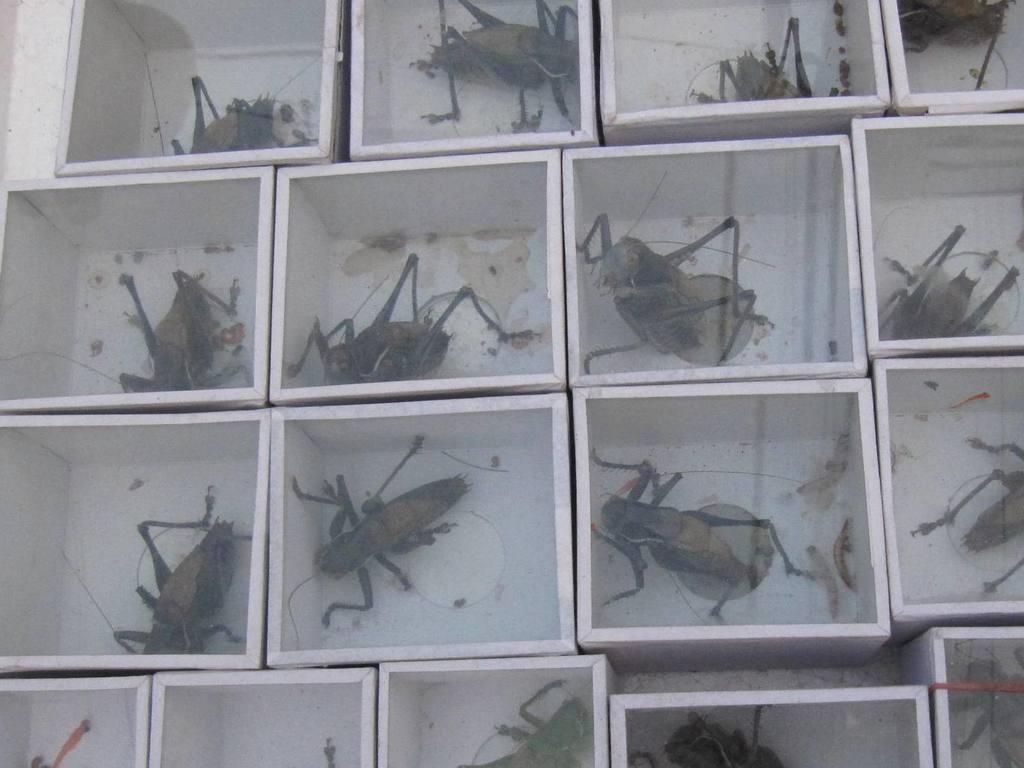Could you give a brief overview of what you see in this image? In this image I can see few boxes. In each and every box there is an insect. 